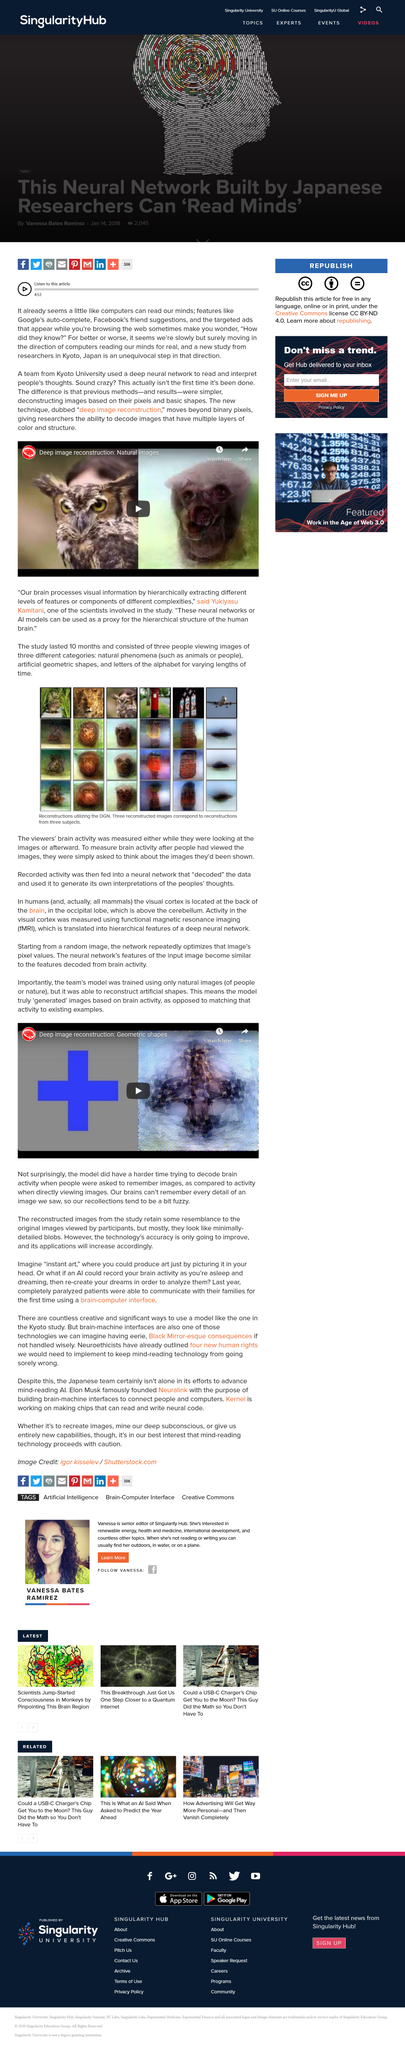Outline some significant characteristics in this image. The bottom three images in each column of the array represent reconstructions from three subjects utilizing a particular technique or method. Previous methods of reading and interpreting people's thoughts involved deconstructing images based on their pixels and basic shapes, leading to a limited understanding of human cognition and perception. The team's model was trained using only natural images, demonstrating their commitment to creating an effective and reliable model. The study lasted for a duration of 10 months. The study involved viewing three categories of images: natural phenomena, artificial geometric shapes, and letters of the alphabet. 